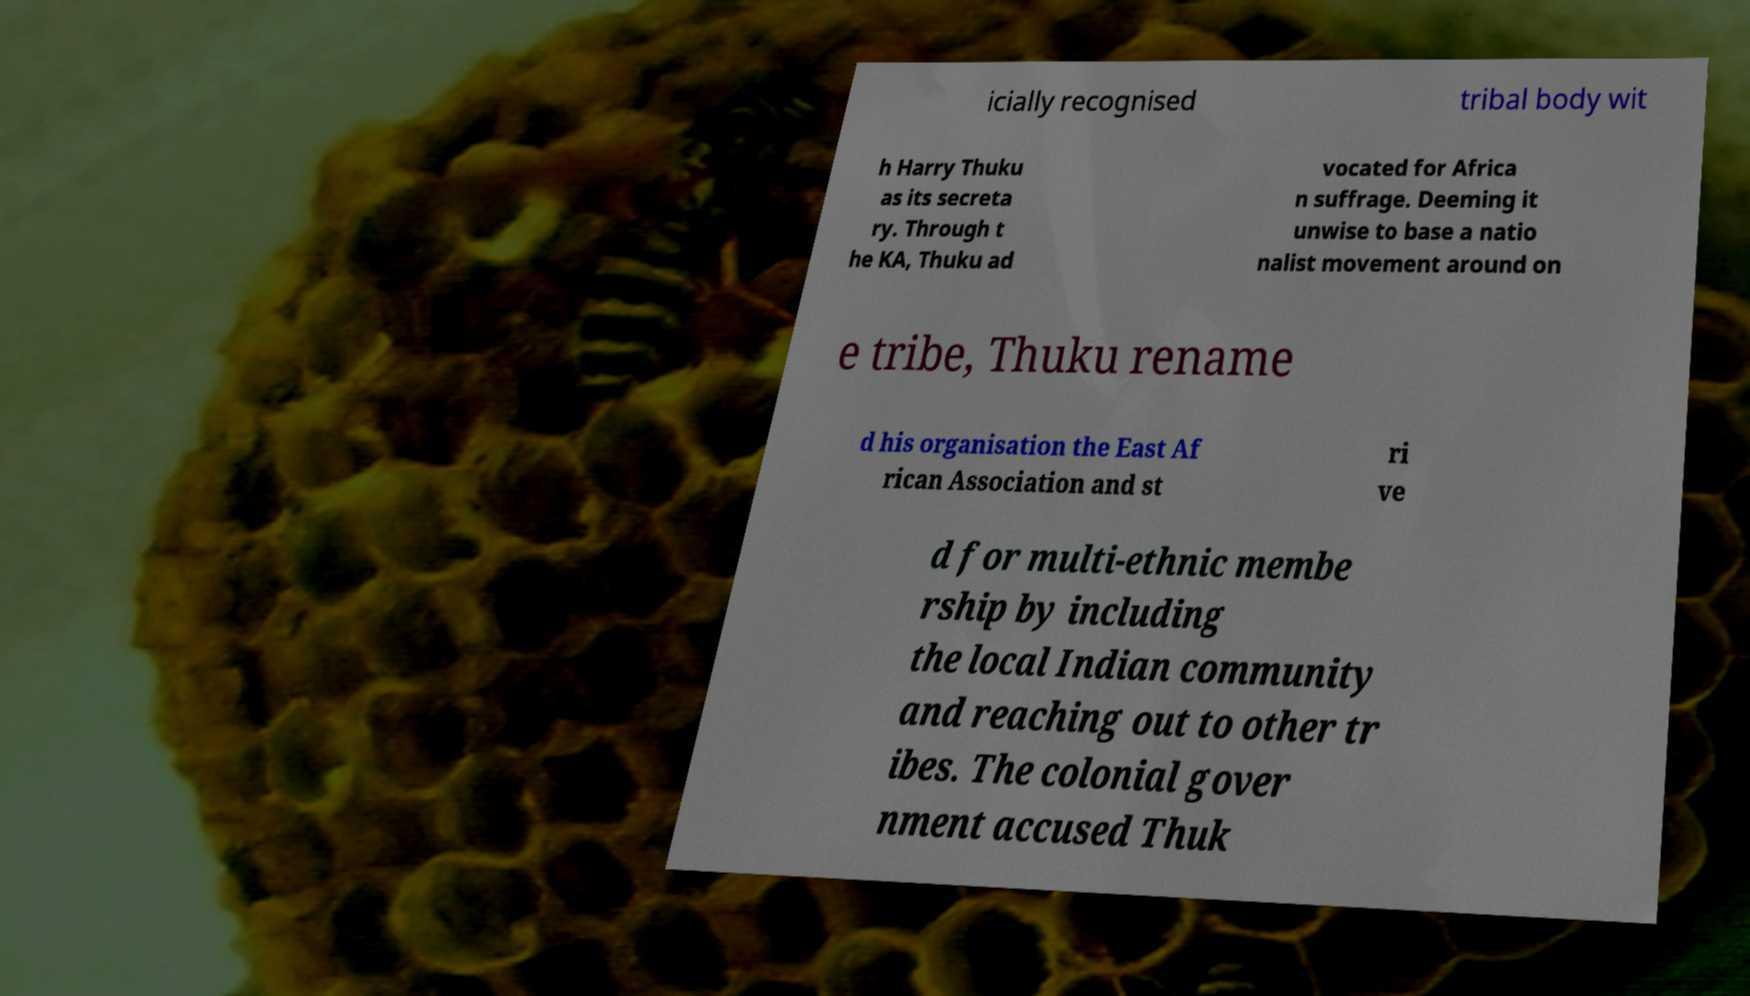Could you extract and type out the text from this image? icially recognised tribal body wit h Harry Thuku as its secreta ry. Through t he KA, Thuku ad vocated for Africa n suffrage. Deeming it unwise to base a natio nalist movement around on e tribe, Thuku rename d his organisation the East Af rican Association and st ri ve d for multi-ethnic membe rship by including the local Indian community and reaching out to other tr ibes. The colonial gover nment accused Thuk 